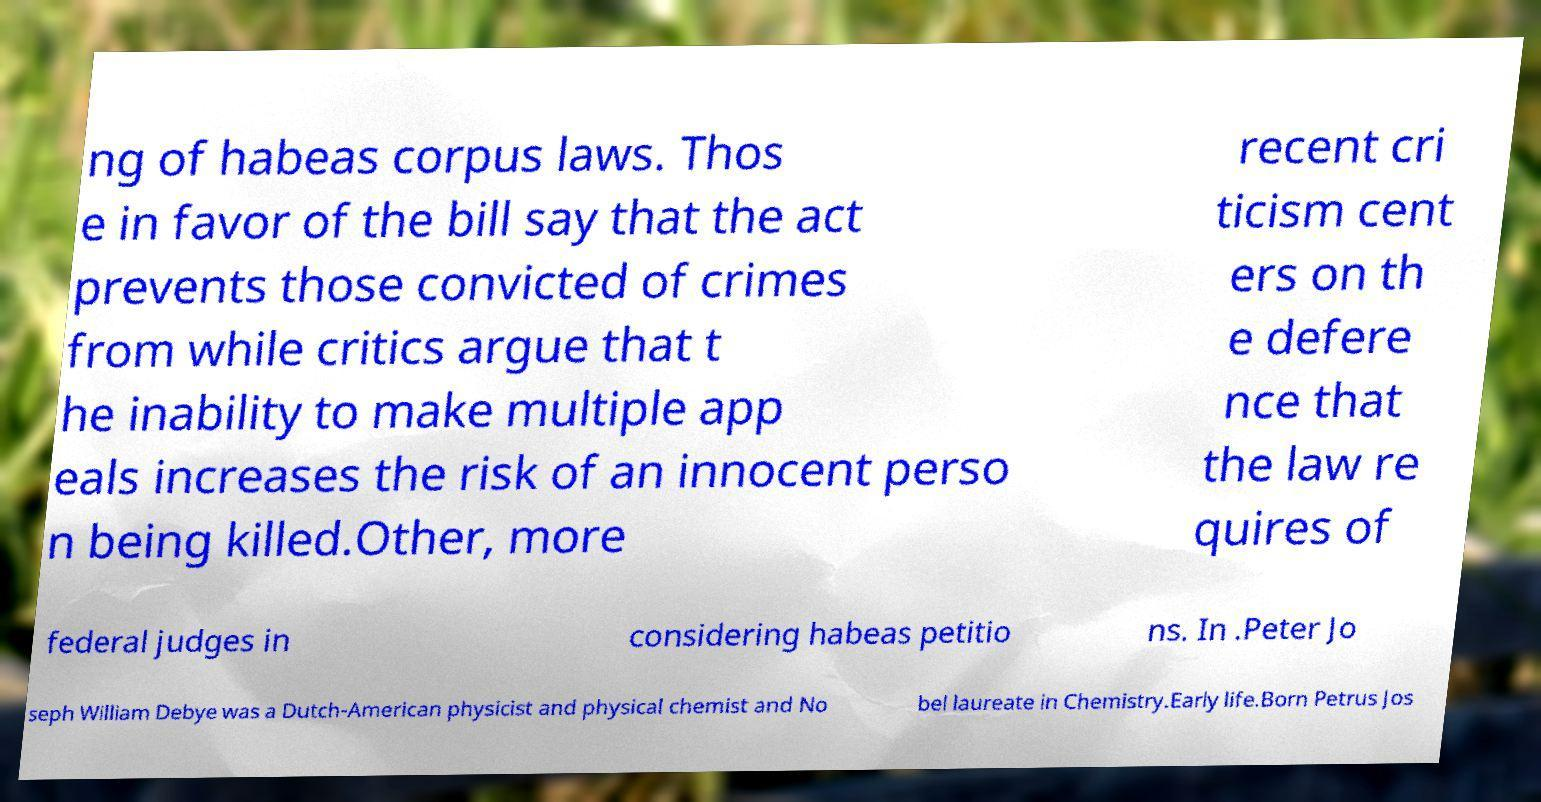Please read and relay the text visible in this image. What does it say? ng of habeas corpus laws. Thos e in favor of the bill say that the act prevents those convicted of crimes from while critics argue that t he inability to make multiple app eals increases the risk of an innocent perso n being killed.Other, more recent cri ticism cent ers on th e defere nce that the law re quires of federal judges in considering habeas petitio ns. In .Peter Jo seph William Debye was a Dutch-American physicist and physical chemist and No bel laureate in Chemistry.Early life.Born Petrus Jos 